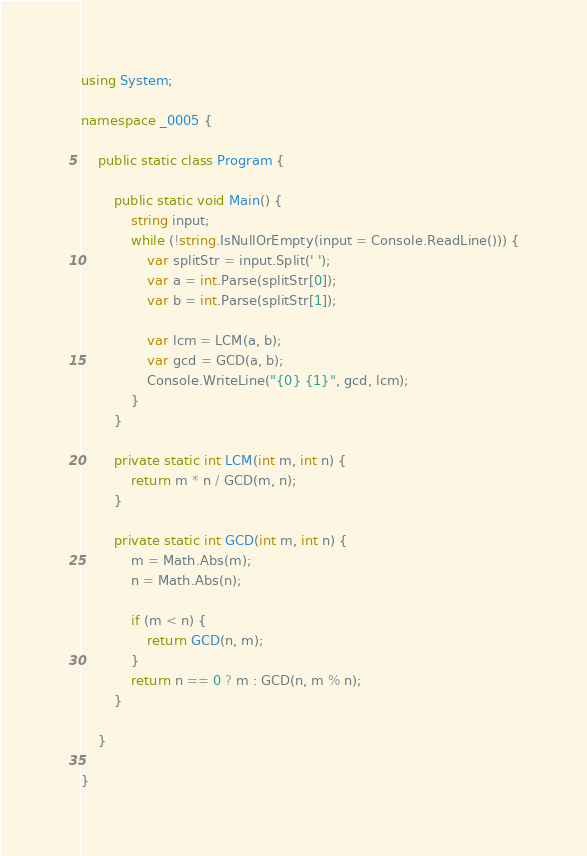Convert code to text. <code><loc_0><loc_0><loc_500><loc_500><_C#_>using System;

namespace _0005 {

	public static class Program {

		public static void Main() {
			string input;
			while (!string.IsNullOrEmpty(input = Console.ReadLine())) {
				var splitStr = input.Split(' ');
				var a = int.Parse(splitStr[0]);
				var b = int.Parse(splitStr[1]);

				var lcm = LCM(a, b);
				var gcd = GCD(a, b);
				Console.WriteLine("{0} {1}", gcd, lcm);
			}
		}

		private static int LCM(int m, int n) {
			return m * n / GCD(m, n);
		}

		private static int GCD(int m, int n) {
			m = Math.Abs(m);
			n = Math.Abs(n);

			if (m < n) {
				return GCD(n, m);
			}
			return n == 0 ? m : GCD(n, m % n);
		}

	}

}</code> 